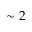Convert formula to latex. <formula><loc_0><loc_0><loc_500><loc_500>\sim 2</formula> 